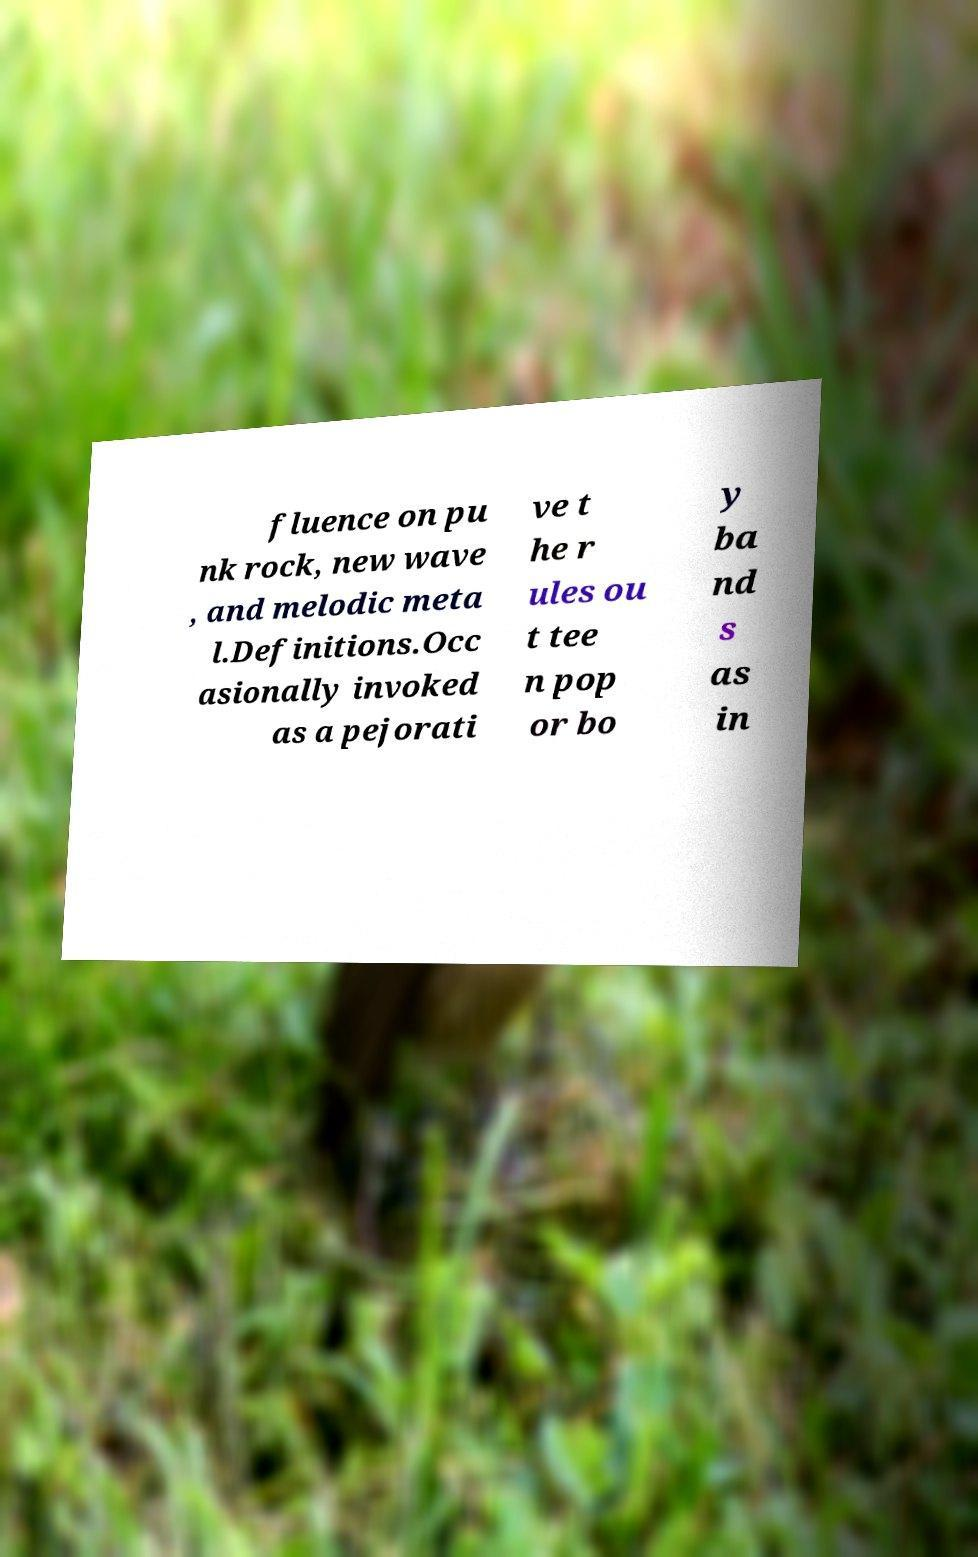What messages or text are displayed in this image? I need them in a readable, typed format. fluence on pu nk rock, new wave , and melodic meta l.Definitions.Occ asionally invoked as a pejorati ve t he r ules ou t tee n pop or bo y ba nd s as in 